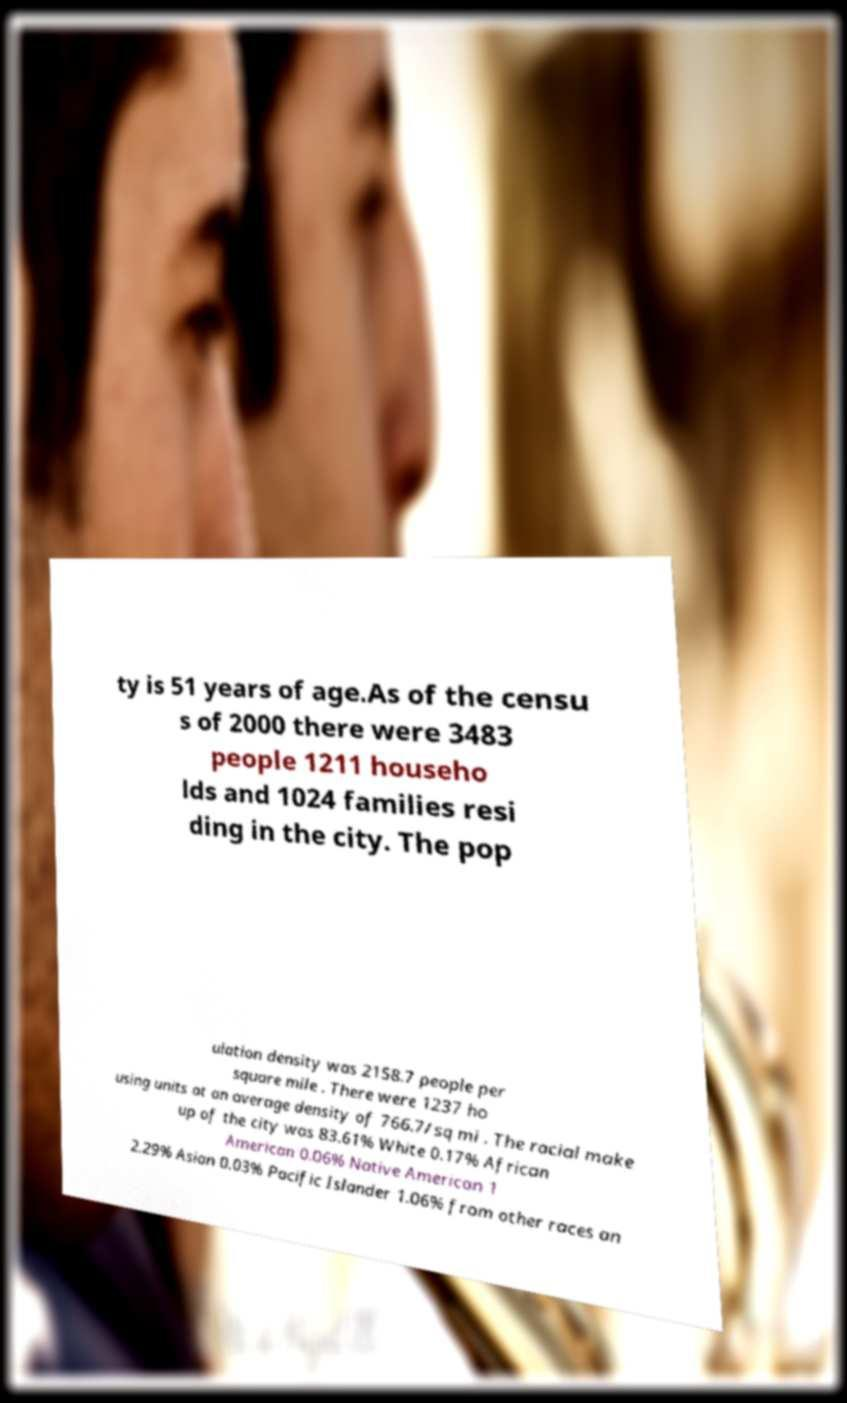What messages or text are displayed in this image? I need them in a readable, typed format. ty is 51 years of age.As of the censu s of 2000 there were 3483 people 1211 househo lds and 1024 families resi ding in the city. The pop ulation density was 2158.7 people per square mile . There were 1237 ho using units at an average density of 766.7/sq mi . The racial make up of the city was 83.61% White 0.17% African American 0.06% Native American 1 2.29% Asian 0.03% Pacific Islander 1.06% from other races an 